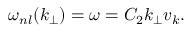Convert formula to latex. <formula><loc_0><loc_0><loc_500><loc_500>\omega _ { n l } ( k _ { \perp } ) = \omega = C _ { 2 } k _ { \perp } v _ { k } .</formula> 